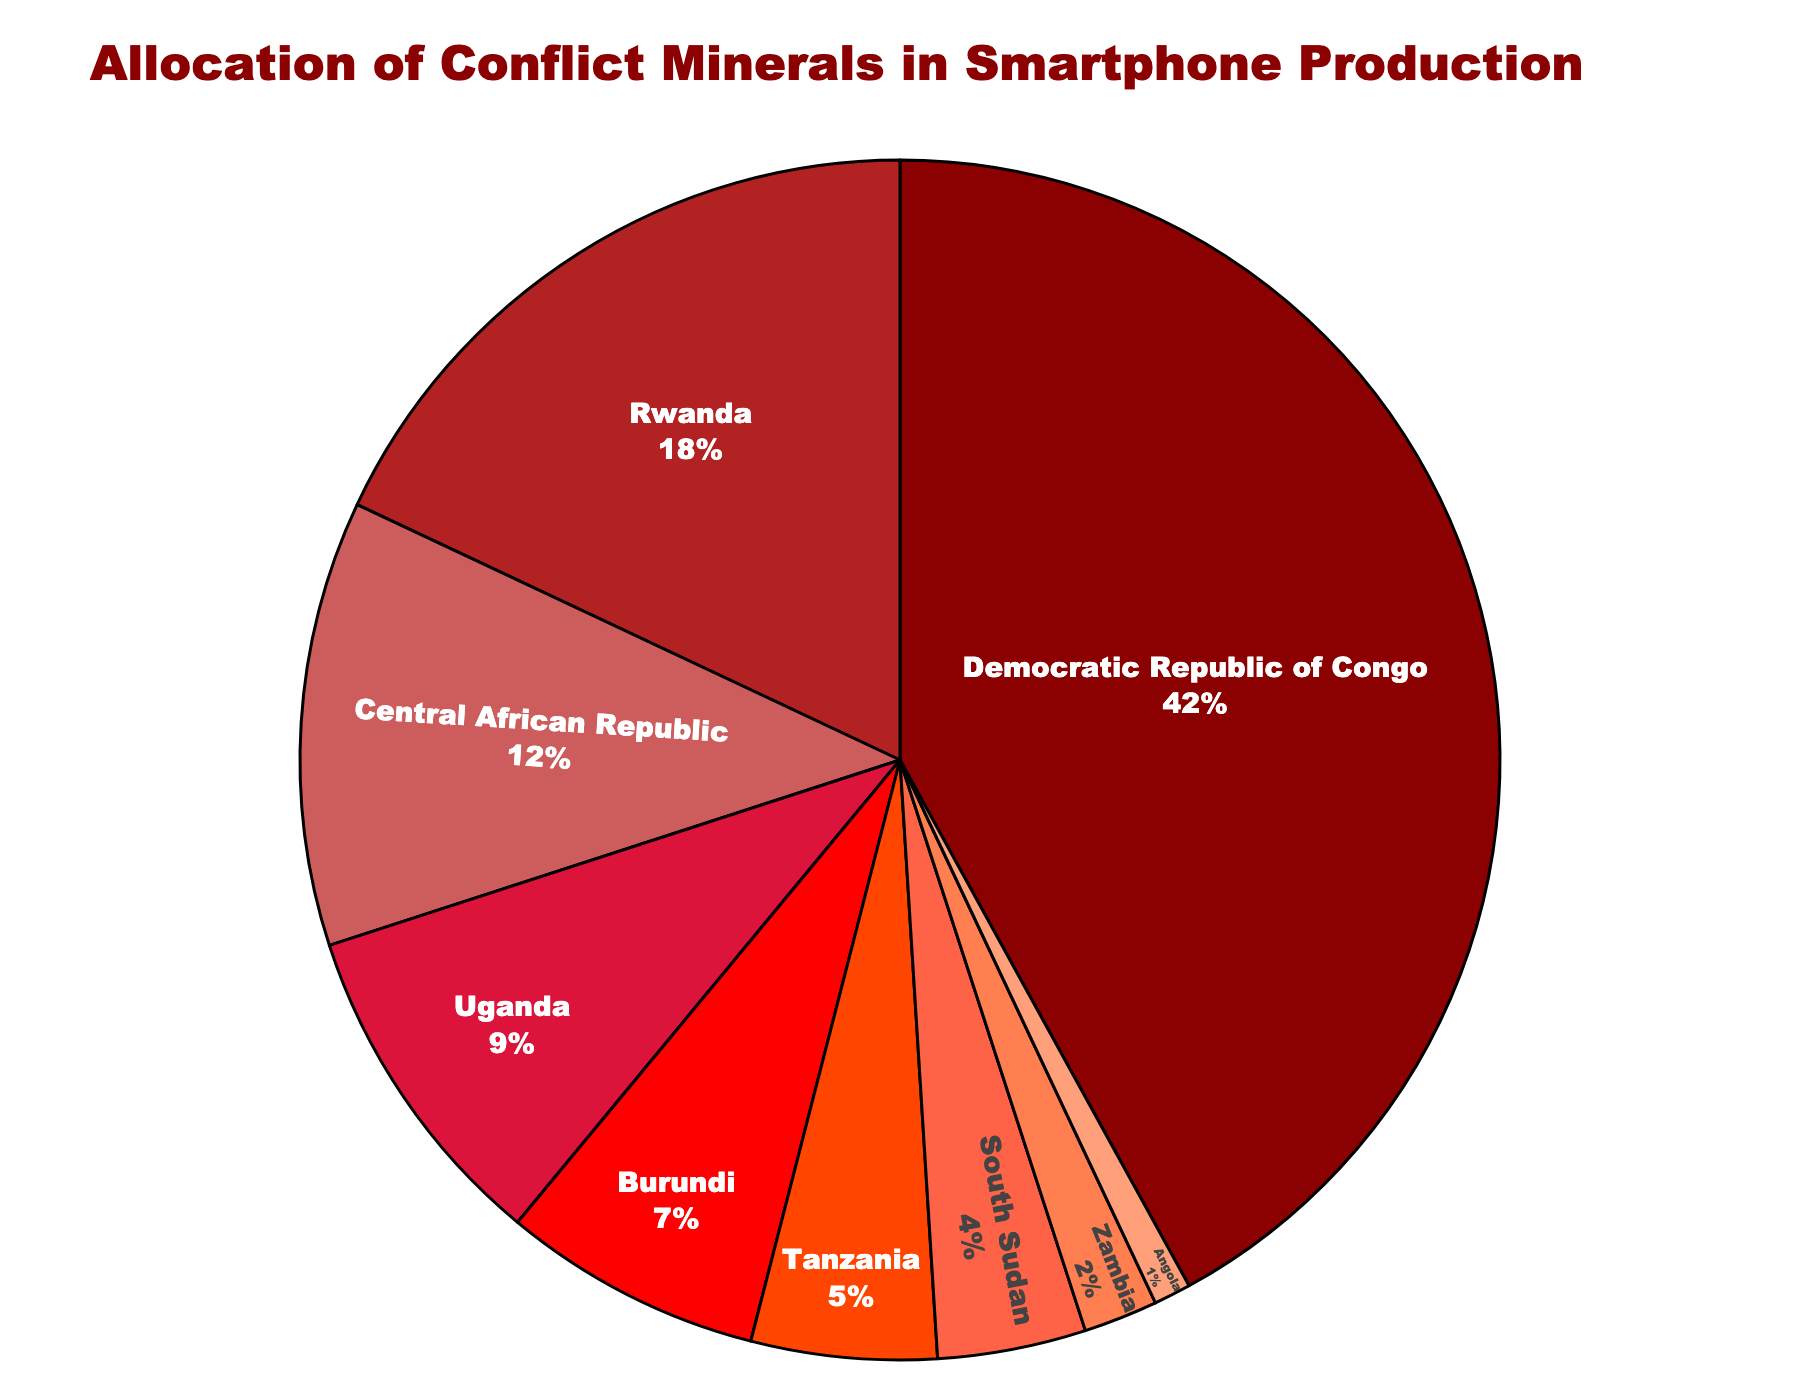What region has the highest allocation of conflict minerals? The pie chart shows the allocation percentages for various regions. The Democratic Republic of Congo has the largest segment, which corresponds to 42%.
Answer: Democratic Republic of Congo Which two regions combined use the same percentage of conflict minerals as Rwanda alone? Rwanda uses 18%. Adding percentages of Uganda (9%) and Burundi (7%) gives 16%, which is closest. However, adding Uganda (9%) and Central African Republic (12%) gives 21%, which is closer.
Answer: Uganda and Central African Republic How much more is the percentage allocation of conflict minerals in Tanzania than in Zambia? Tanzania has 5% and Zambia has 2%. The difference is calculated as 5% - 2% = 3%.
Answer: 3% Which regions have a combined percentage allocation of less than 10%? The regions are Zambia (2%) and Angola (1%), totaling 2% + 1% = 3%.
Answer: Zambia and Angola What is the combined percentage allocation for the top three regions? The top three regions are Democratic Republic of Congo (42%), Rwanda (18%), and Central African Republic (12%). The combined percentage is 42% + 18% + 12% = 72%.
Answer: 72% Is the percentage allocation of conflict minerals in Burundi more than that in Uganda? The chart shows Burundi at 7% and Uganda at 9%. 7% is less than 9%.
Answer: No Which region's percentage allocation is approximately half of the Democratic Republic of Congo? The Democratic Republic of Congo has 42%. Approximately half is 21%. The Central African Republic has 12%, while Rwanda has 18%, closer to the half value.
Answer: Rwanda Compare the cumulative percentage of conflict minerals used by Zambia, Angola, and South Sudan to that used by Rwanda. Zambia (2%), Angola (1%), and South Sudan (4%) together have a cumulative percentage of 2% + 1% + 4% = 7%. Rwanda alone has 18%.
Answer: Rwanda What is the visual color for the segment representing Uganda? The color sequence indicates Uganda's segment is represented with orange.
Answer: Orange What regions collectively make up more than half of the total conflict mineral allocation? Collectively, Democratic Republic of Congo (42%) and Rwanda (18%) together make 42% + 18% = 60%, which is more than half.
Answer: Democratic Republic of Congo and Rwanda 